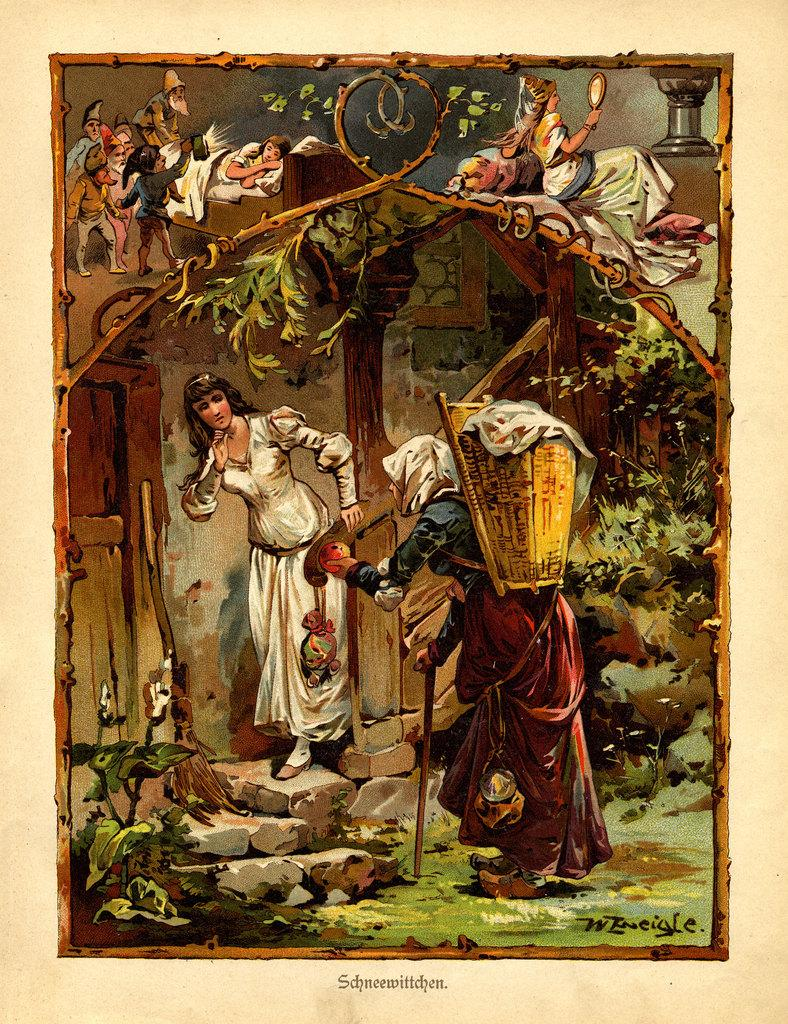What is featured on the poster in the image? The poster contains images of people. What other elements can be seen in the image besides the poster? There are plants, rocks, a wall, and text at the bottom of the image. What type of prose is written on the garden wall in the image? There is no garden or prose present in the image; it features a poster with images of people, plants, rocks, a wall, and text at the bottom. 